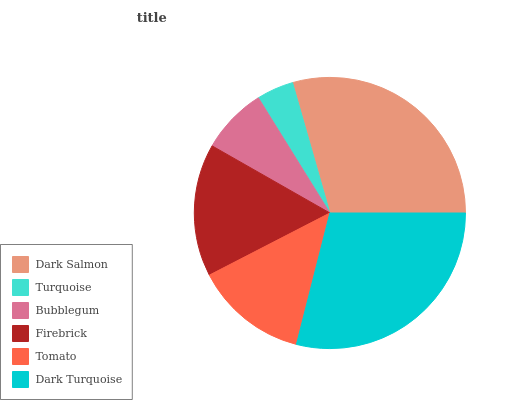Is Turquoise the minimum?
Answer yes or no. Yes. Is Dark Salmon the maximum?
Answer yes or no. Yes. Is Bubblegum the minimum?
Answer yes or no. No. Is Bubblegum the maximum?
Answer yes or no. No. Is Bubblegum greater than Turquoise?
Answer yes or no. Yes. Is Turquoise less than Bubblegum?
Answer yes or no. Yes. Is Turquoise greater than Bubblegum?
Answer yes or no. No. Is Bubblegum less than Turquoise?
Answer yes or no. No. Is Firebrick the high median?
Answer yes or no. Yes. Is Tomato the low median?
Answer yes or no. Yes. Is Bubblegum the high median?
Answer yes or no. No. Is Dark Turquoise the low median?
Answer yes or no. No. 